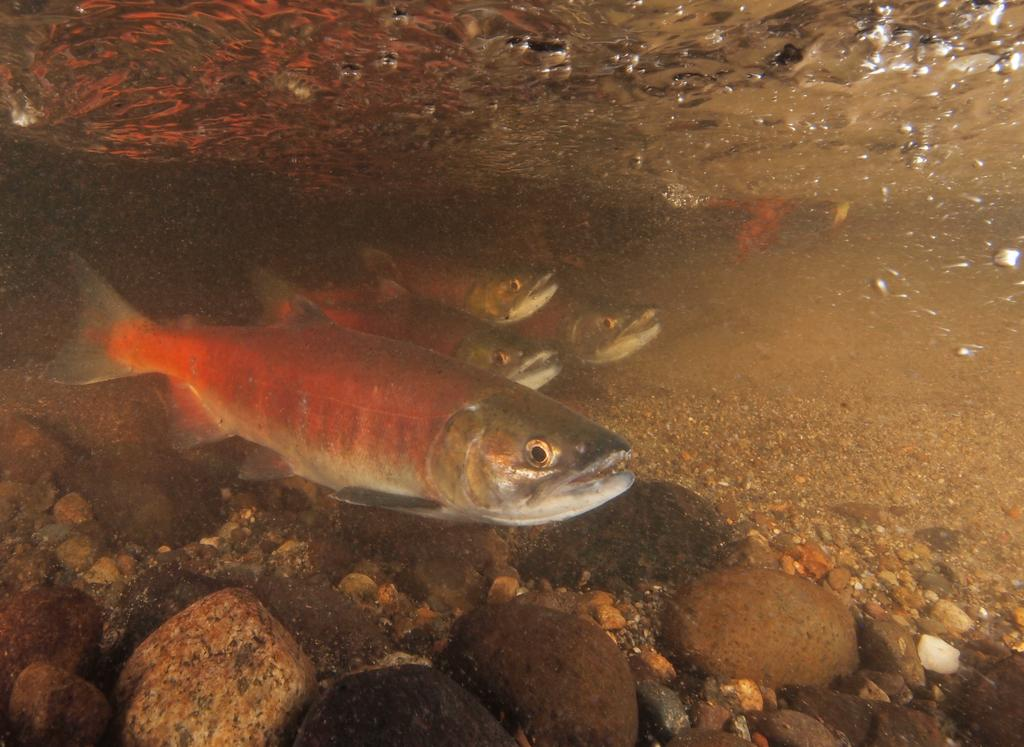What type of animals can be seen in the image? There are fishes in the image. What other objects can be seen in the image? There are stones in the image. Where are the fishes and stones located? The fishes and stones are in the water. What type of bells can be heard ringing in the image? There are no bells present in the image, and therefore no sound can be heard. 